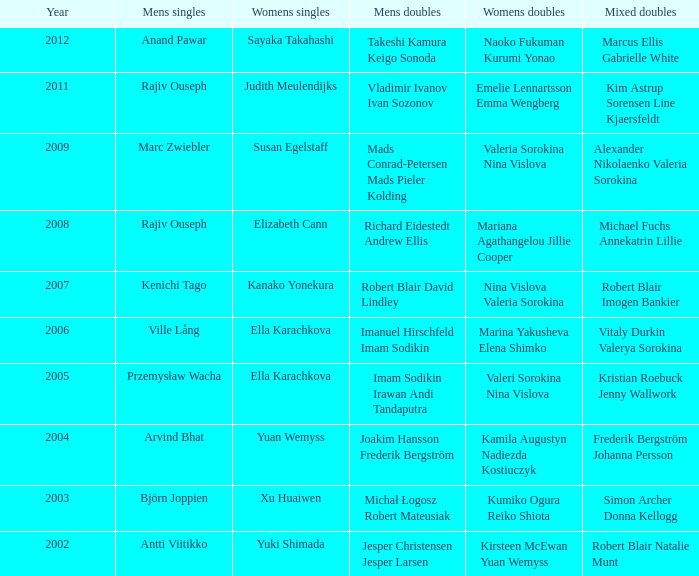List the men's singles with marina yakusheva elena shimko. Ville Lång. 